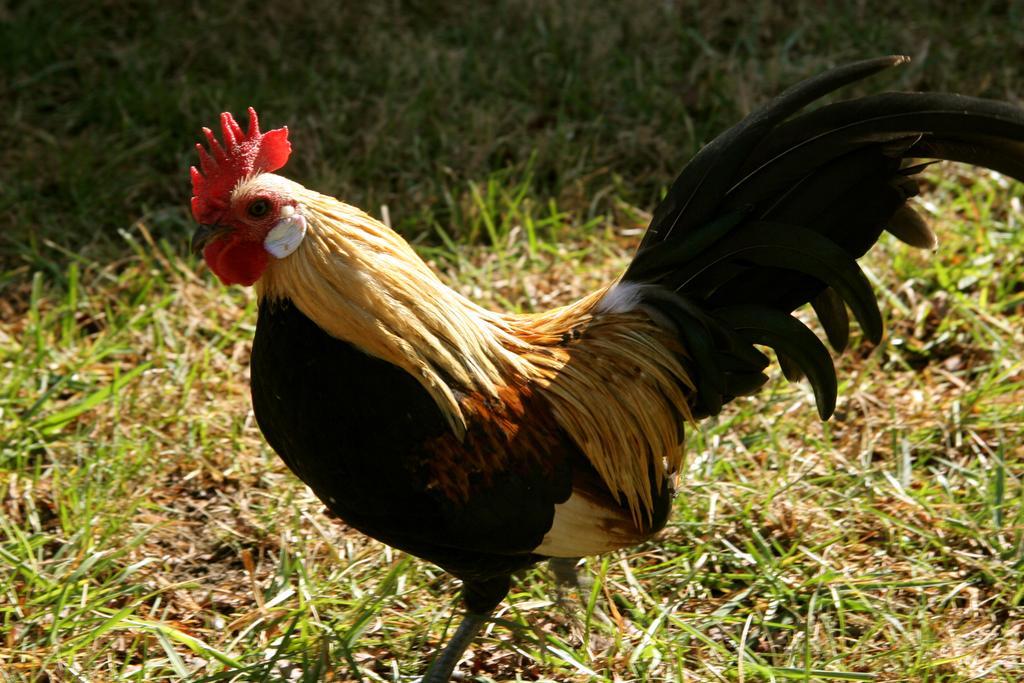Describe this image in one or two sentences. In this image there is a cock standing on the ground. There is grass on the ground. 